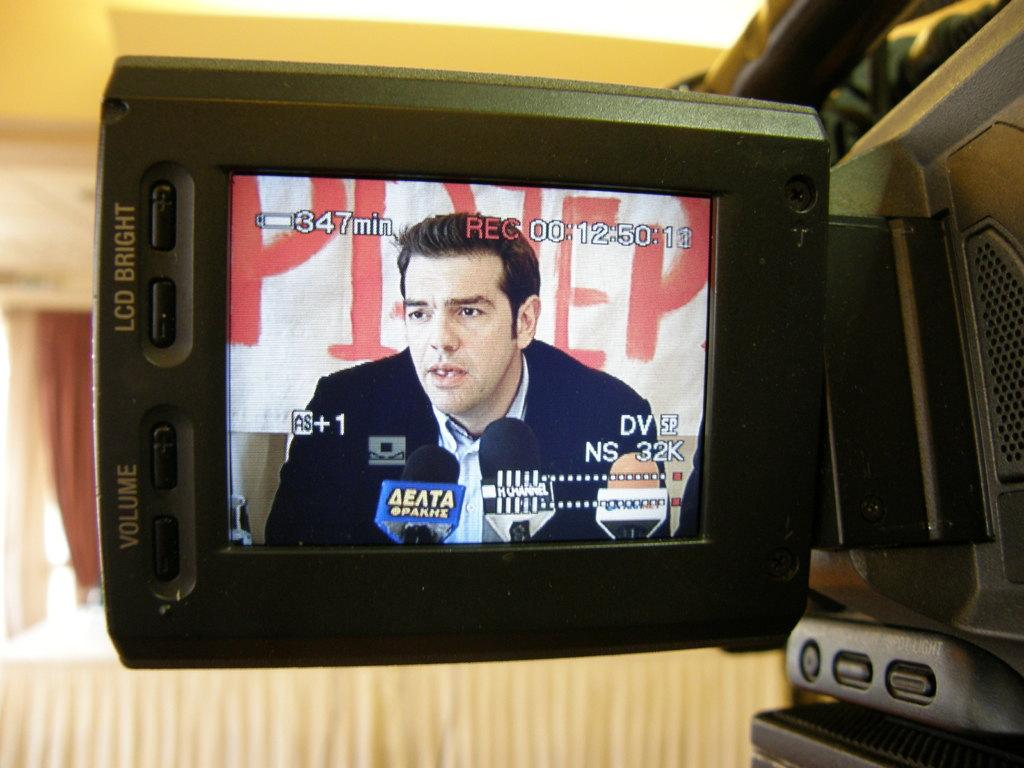<image>
Offer a succinct explanation of the picture presented. 347 minutes of battery life and 00:12:50:12 recorded time are shown on the screen. 